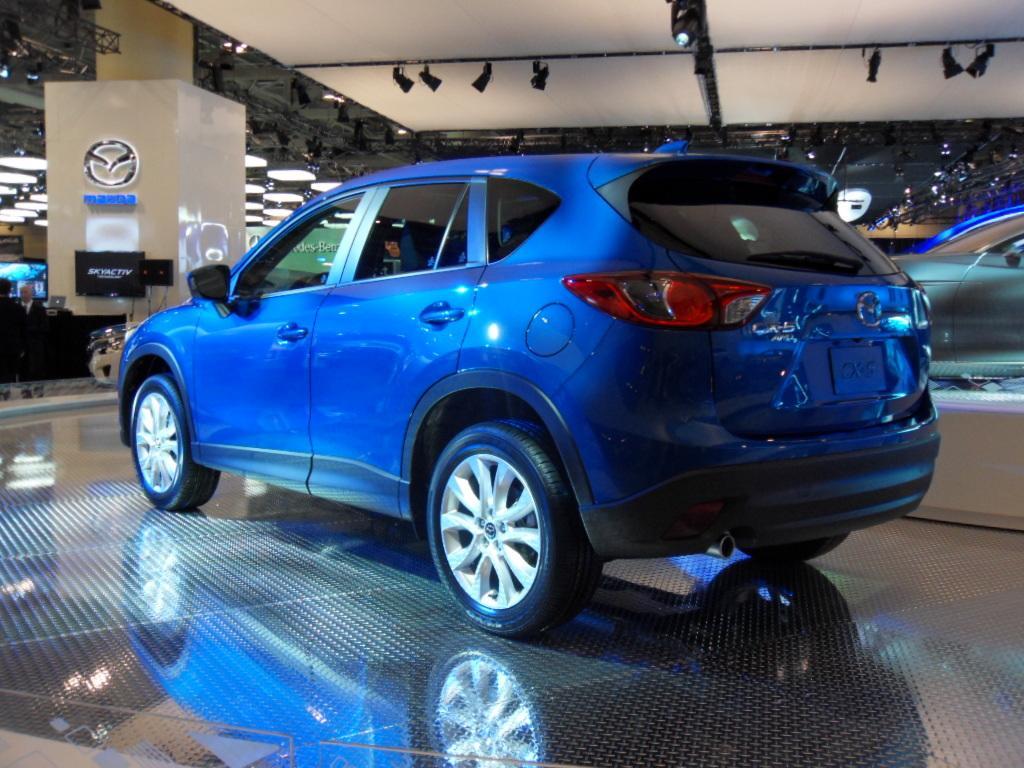Describe this image in one or two sentences. In the image we can see a vehicle blue in color, this is a floor. There are people wearing clothes, this is a logo. 